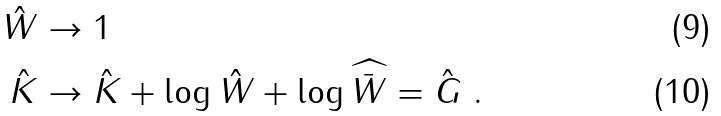Convert formula to latex. <formula><loc_0><loc_0><loc_500><loc_500>\hat { W } & \to 1 \\ \hat { K } & \to \hat { K } + \log \hat { W } + \log \widehat { \bar { W } } = \hat { G } \ .</formula> 